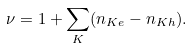Convert formula to latex. <formula><loc_0><loc_0><loc_500><loc_500>\nu = 1 + \sum _ { K } ( n _ { K e } - n _ { K h } ) .</formula> 